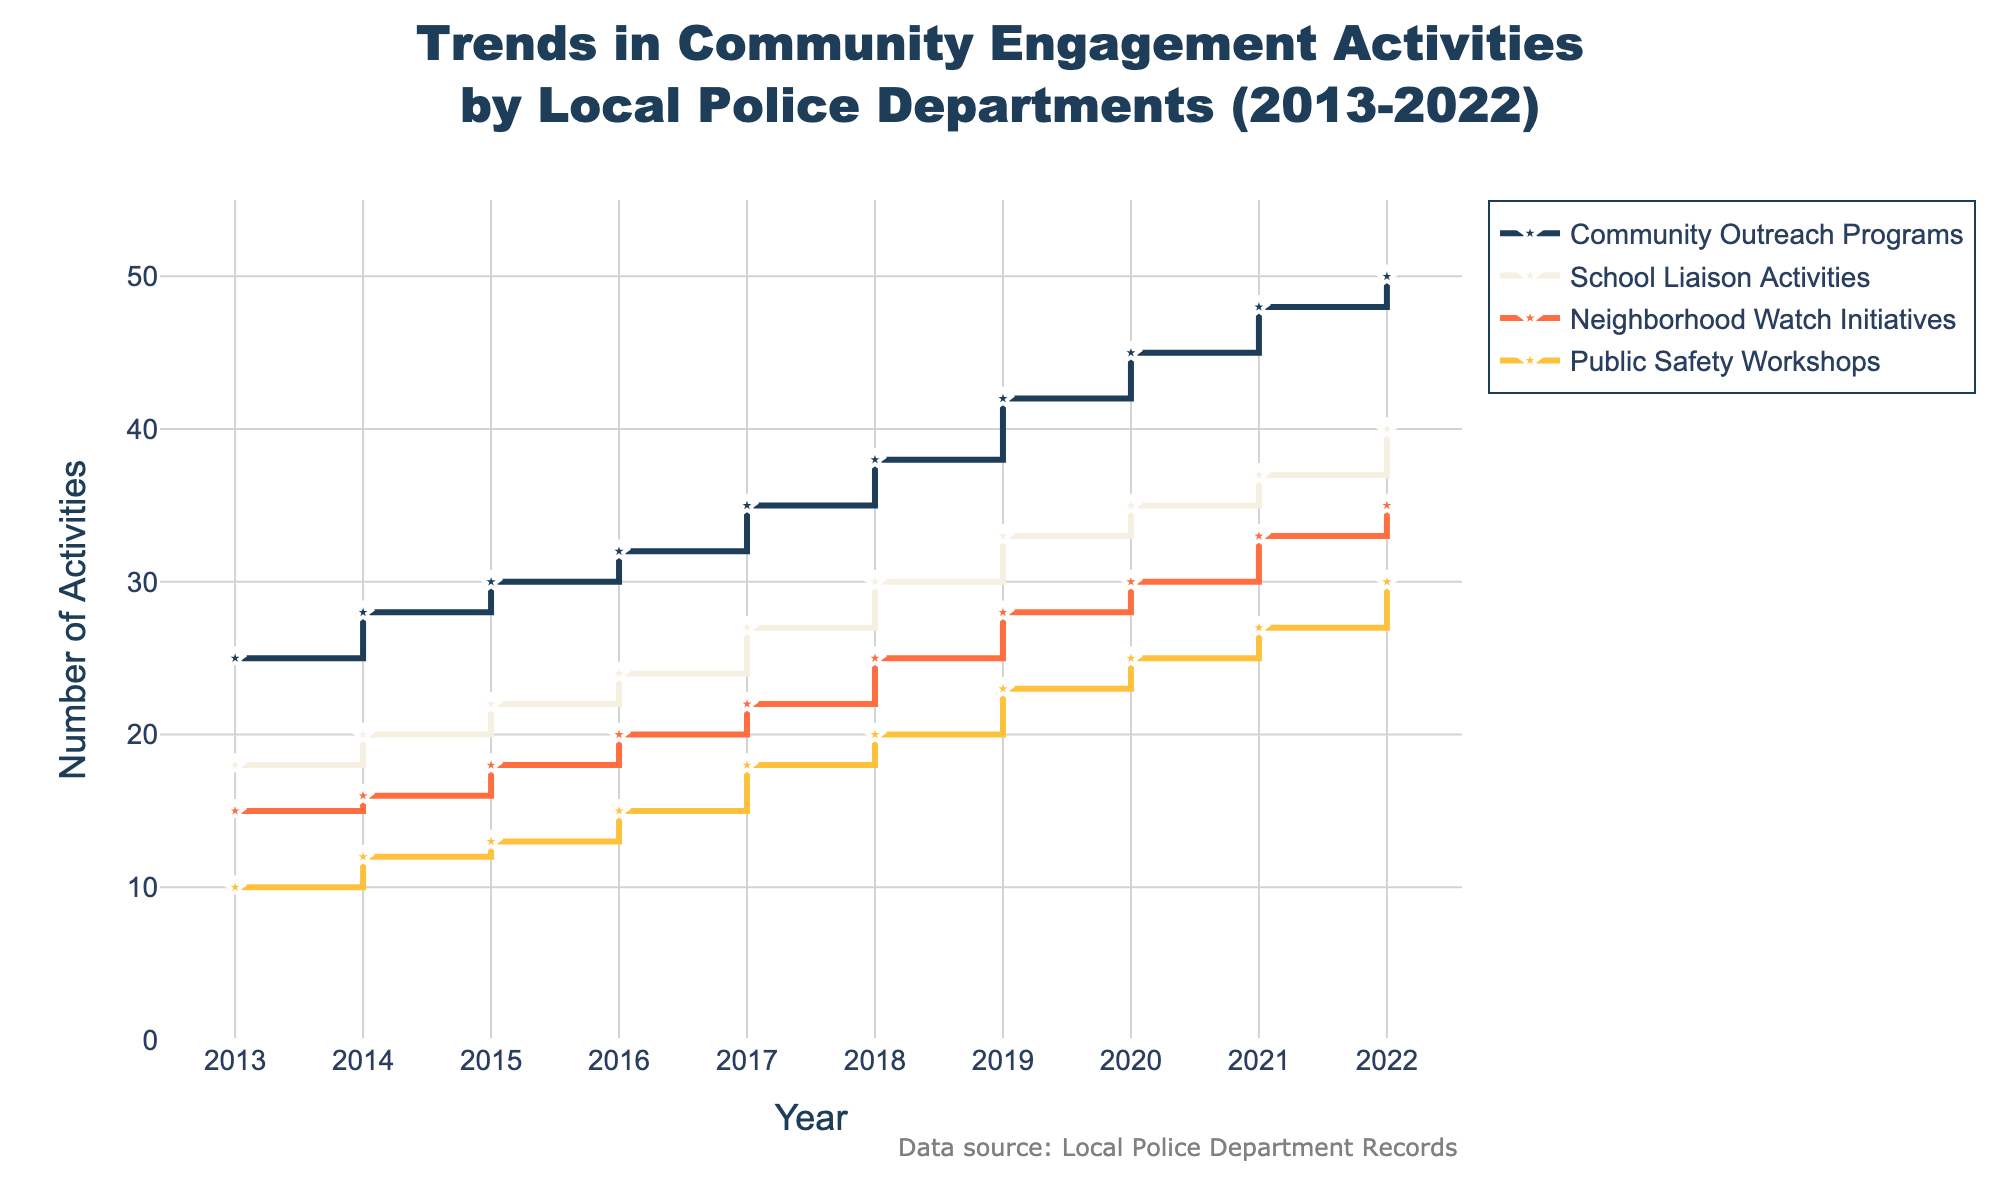What's the total number of Neighborhood Watch Initiatives and Public Safety Workshops in 2017? In 2017, the number of Neighborhood Watch Initiatives is 22 and the number of Public Safety Workshops is 18. Adding these gives 22 + 18 = 40.
Answer: 40 Which year shows the highest participation in Community Outreach Programs? By inspecting the figure, the number of Community Outreach Programs increases each year. The highest number is observed in 2022, which has 50 activities.
Answer: 2022 How many years have the School Liaison Activities and Neighborhood Watch Initiatives both increased every year from 2013 to 2022? By checking the figure, both School Liaison Activities and Neighborhood Watch Initiatives consistently increase each year, from 2013 to 2022 inclusive. This corresponds to 10 years (2013-2022).
Answer: 10 What is the difference in the number of Public Safety Workshops between the years 2016 and 2022? In 2016, there are 15 Public Safety Workshops, and in 2022 there are 30. The difference is 30 - 15 = 15.
Answer: 15 During which year was the increase in Community Outreach Programs highest compared to the previous year? By examining the slope between consecutive years in the Community Outreach Programs line, the largest single increase is from 2018 to 2019, which is from 38 to 42 (increase of 4).
Answer: 2019 What is the average number of School Liaison Activities from 2013 to 2022? Adding the number of School Liaison Activities for each year (18 + 20 + 22 + 24 + 27 + 30 + 33 + 35 + 37 + 40) and dividing by 10 gives the average: (286) / 10 = 28.6.
Answer: 28.6 In which year did Neighborhood Watch Initiatives and Public Safety Workshops have equal numbers? By inspecting the graph, there is no year where Neighborhood Watch Initiatives and Public Safety Workshops have equal numbers.
Answer: None Which category showed the smallest increase from 2013 to 2022? By comparing the differences between 2022 and 2013 for each category:
- Community Outreach Programs: 50 - 25 = 25
- School Liaison Activities: 40 - 18 = 22
- Neighborhood Watch Initiatives: 35 - 15 = 20
- Public Safety Workshops: 30 - 10 = 20 
The smallest increase was in Public Safety Workshops and Neighborhood Watch Initiatives, both with an increase of 20.
Answer: Public Safety Workshops and Neighborhood Watch Initiatives Which year had the same number of Community Outreach Programs and Neighborhood Watch Initiatives combined as the total School Liaison Activities in 2021? Checking 2021, School Liaison Activities are 37; checking the combined numbers of Community Outreach Programs and Neighborhood Watch Initiatives:
- 2021: 48 + 33 = 81 
- No other year’s combined total matches this value.
Answer: None 